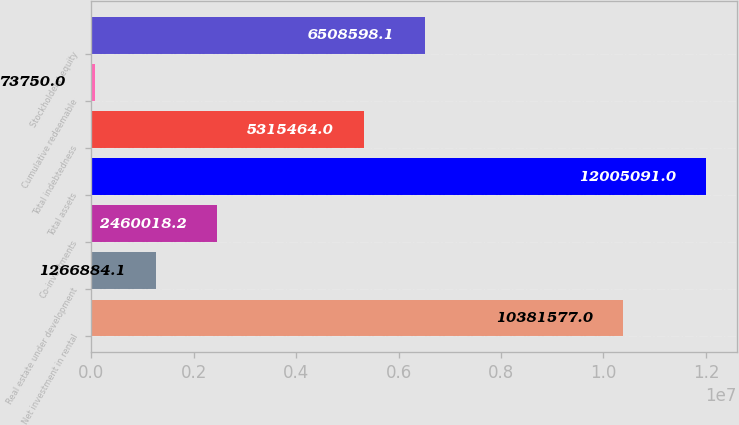<chart> <loc_0><loc_0><loc_500><loc_500><bar_chart><fcel>Net investment in rental<fcel>Real estate under development<fcel>Co-investments<fcel>Total assets<fcel>Total indebtedness<fcel>Cumulative redeemable<fcel>Stockholders' equity<nl><fcel>1.03816e+07<fcel>1.26688e+06<fcel>2.46002e+06<fcel>1.20051e+07<fcel>5.31546e+06<fcel>73750<fcel>6.5086e+06<nl></chart> 